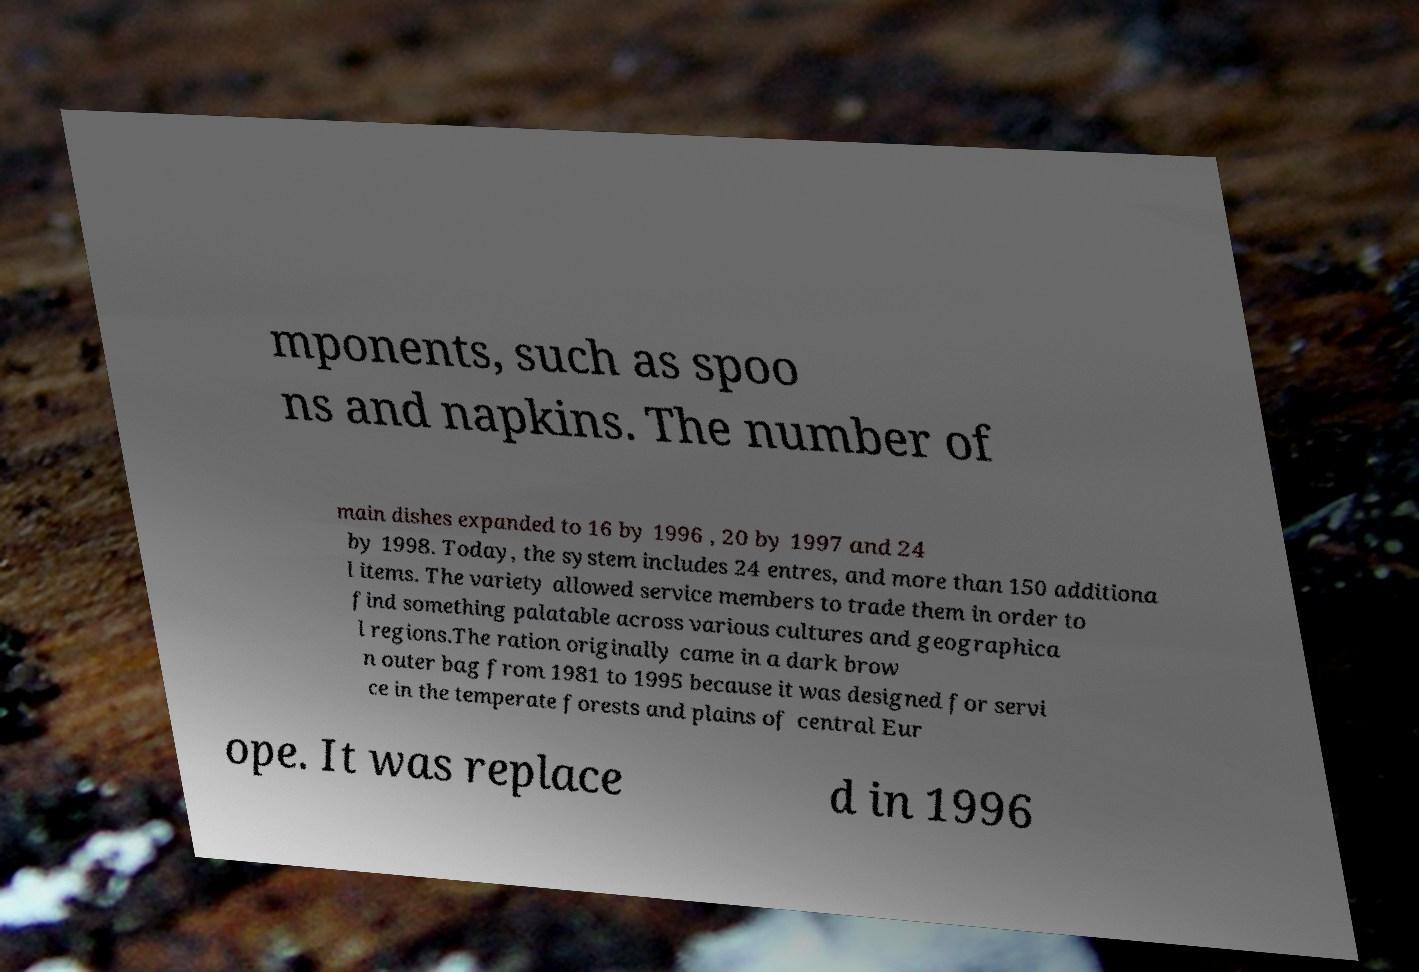Can you read and provide the text displayed in the image?This photo seems to have some interesting text. Can you extract and type it out for me? mponents, such as spoo ns and napkins. The number of main dishes expanded to 16 by 1996 , 20 by 1997 and 24 by 1998. Today, the system includes 24 entres, and more than 150 additiona l items. The variety allowed service members to trade them in order to find something palatable across various cultures and geographica l regions.The ration originally came in a dark brow n outer bag from 1981 to 1995 because it was designed for servi ce in the temperate forests and plains of central Eur ope. It was replace d in 1996 